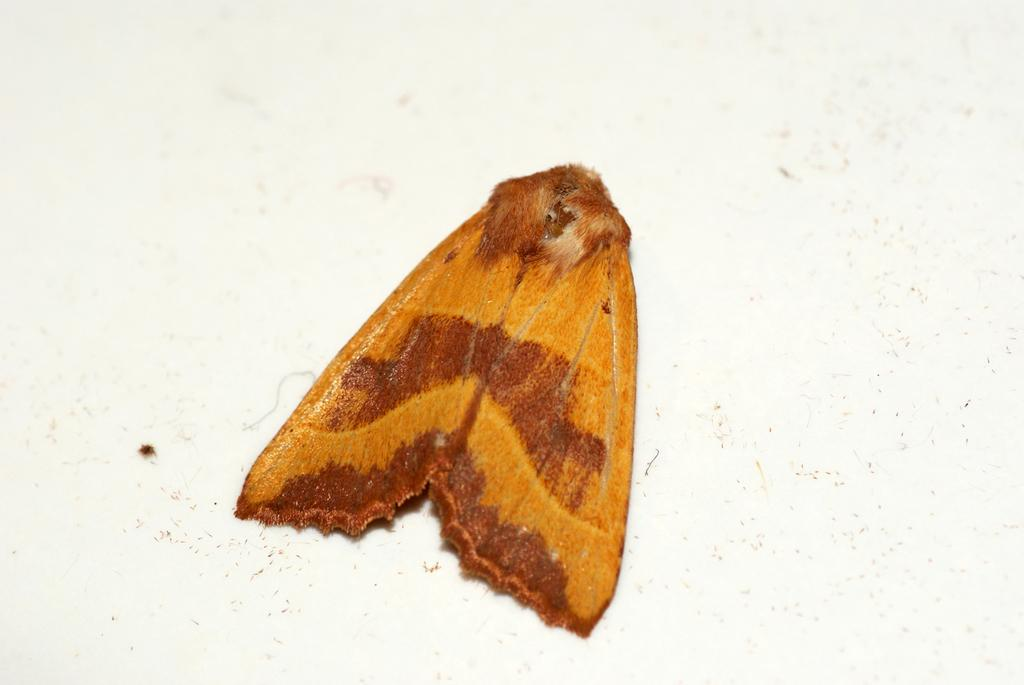What type of insect is in the image? There is a moth in the image. Where is the moth located? The moth is on a surface. What is the price of the eye in the image? There is no eye present in the image, and therefore no price can be determined. 